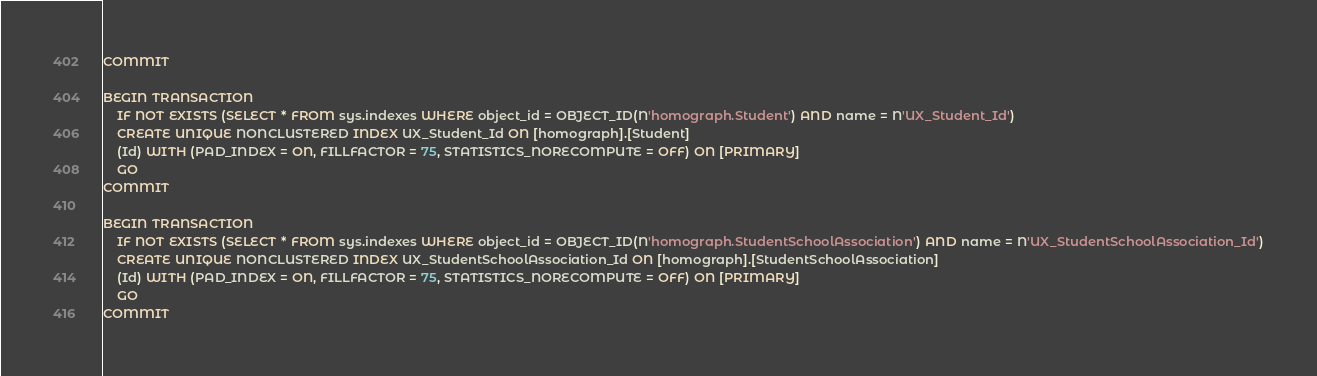<code> <loc_0><loc_0><loc_500><loc_500><_SQL_>COMMIT

BEGIN TRANSACTION
    IF NOT EXISTS (SELECT * FROM sys.indexes WHERE object_id = OBJECT_ID(N'homograph.Student') AND name = N'UX_Student_Id')
    CREATE UNIQUE NONCLUSTERED INDEX UX_Student_Id ON [homograph].[Student]
    (Id) WITH (PAD_INDEX = ON, FILLFACTOR = 75, STATISTICS_NORECOMPUTE = OFF) ON [PRIMARY]
    GO
COMMIT

BEGIN TRANSACTION
    IF NOT EXISTS (SELECT * FROM sys.indexes WHERE object_id = OBJECT_ID(N'homograph.StudentSchoolAssociation') AND name = N'UX_StudentSchoolAssociation_Id')
    CREATE UNIQUE NONCLUSTERED INDEX UX_StudentSchoolAssociation_Id ON [homograph].[StudentSchoolAssociation]
    (Id) WITH (PAD_INDEX = ON, FILLFACTOR = 75, STATISTICS_NORECOMPUTE = OFF) ON [PRIMARY]
    GO
COMMIT

</code> 